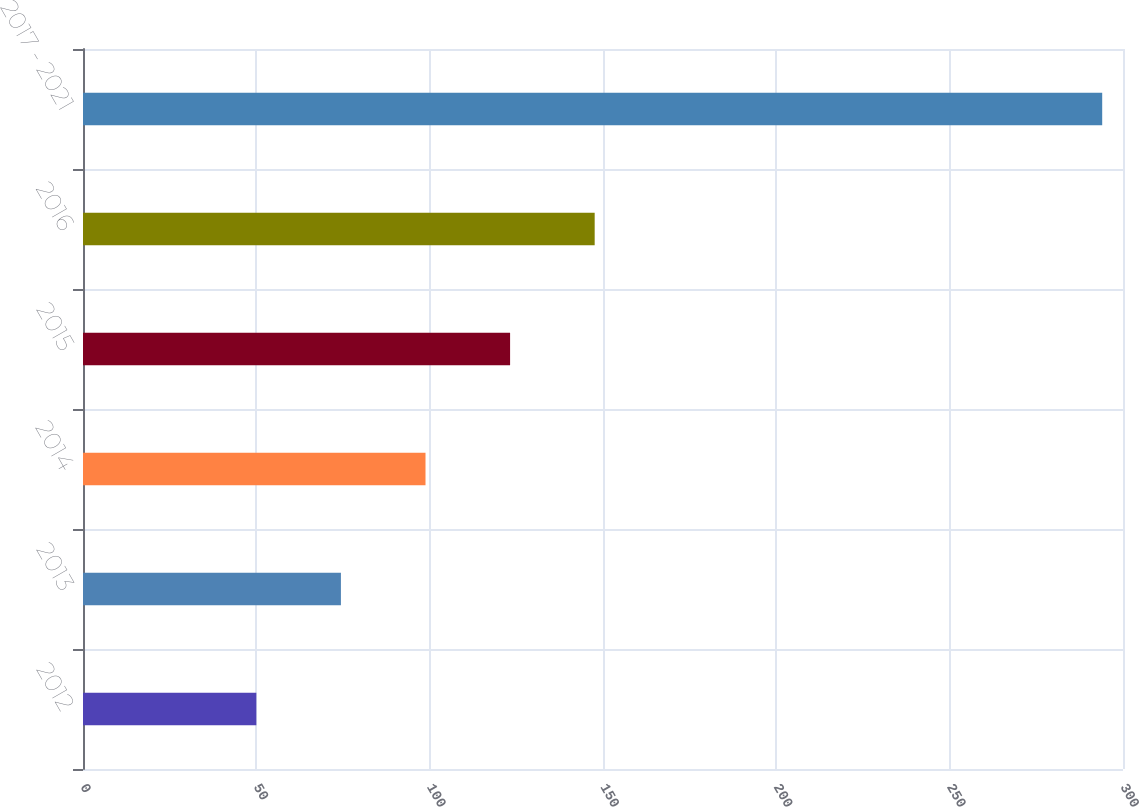Convert chart. <chart><loc_0><loc_0><loc_500><loc_500><bar_chart><fcel>2012<fcel>2013<fcel>2014<fcel>2015<fcel>2016<fcel>2017 - 2021<nl><fcel>50<fcel>74.4<fcel>98.8<fcel>123.2<fcel>147.6<fcel>294<nl></chart> 